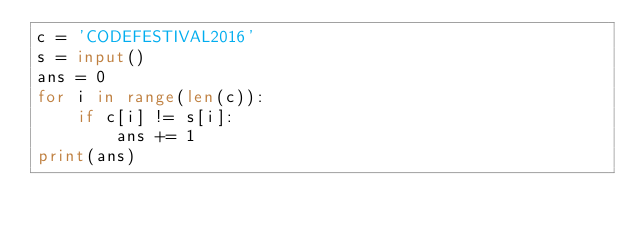Convert code to text. <code><loc_0><loc_0><loc_500><loc_500><_Python_>c = 'CODEFESTIVAL2016'
s = input()
ans = 0
for i in range(len(c)):
    if c[i] != s[i]:
        ans += 1
print(ans)</code> 